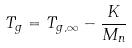<formula> <loc_0><loc_0><loc_500><loc_500>T _ { g } = T _ { g , \infty } - \frac { K } { M _ { n } }</formula> 